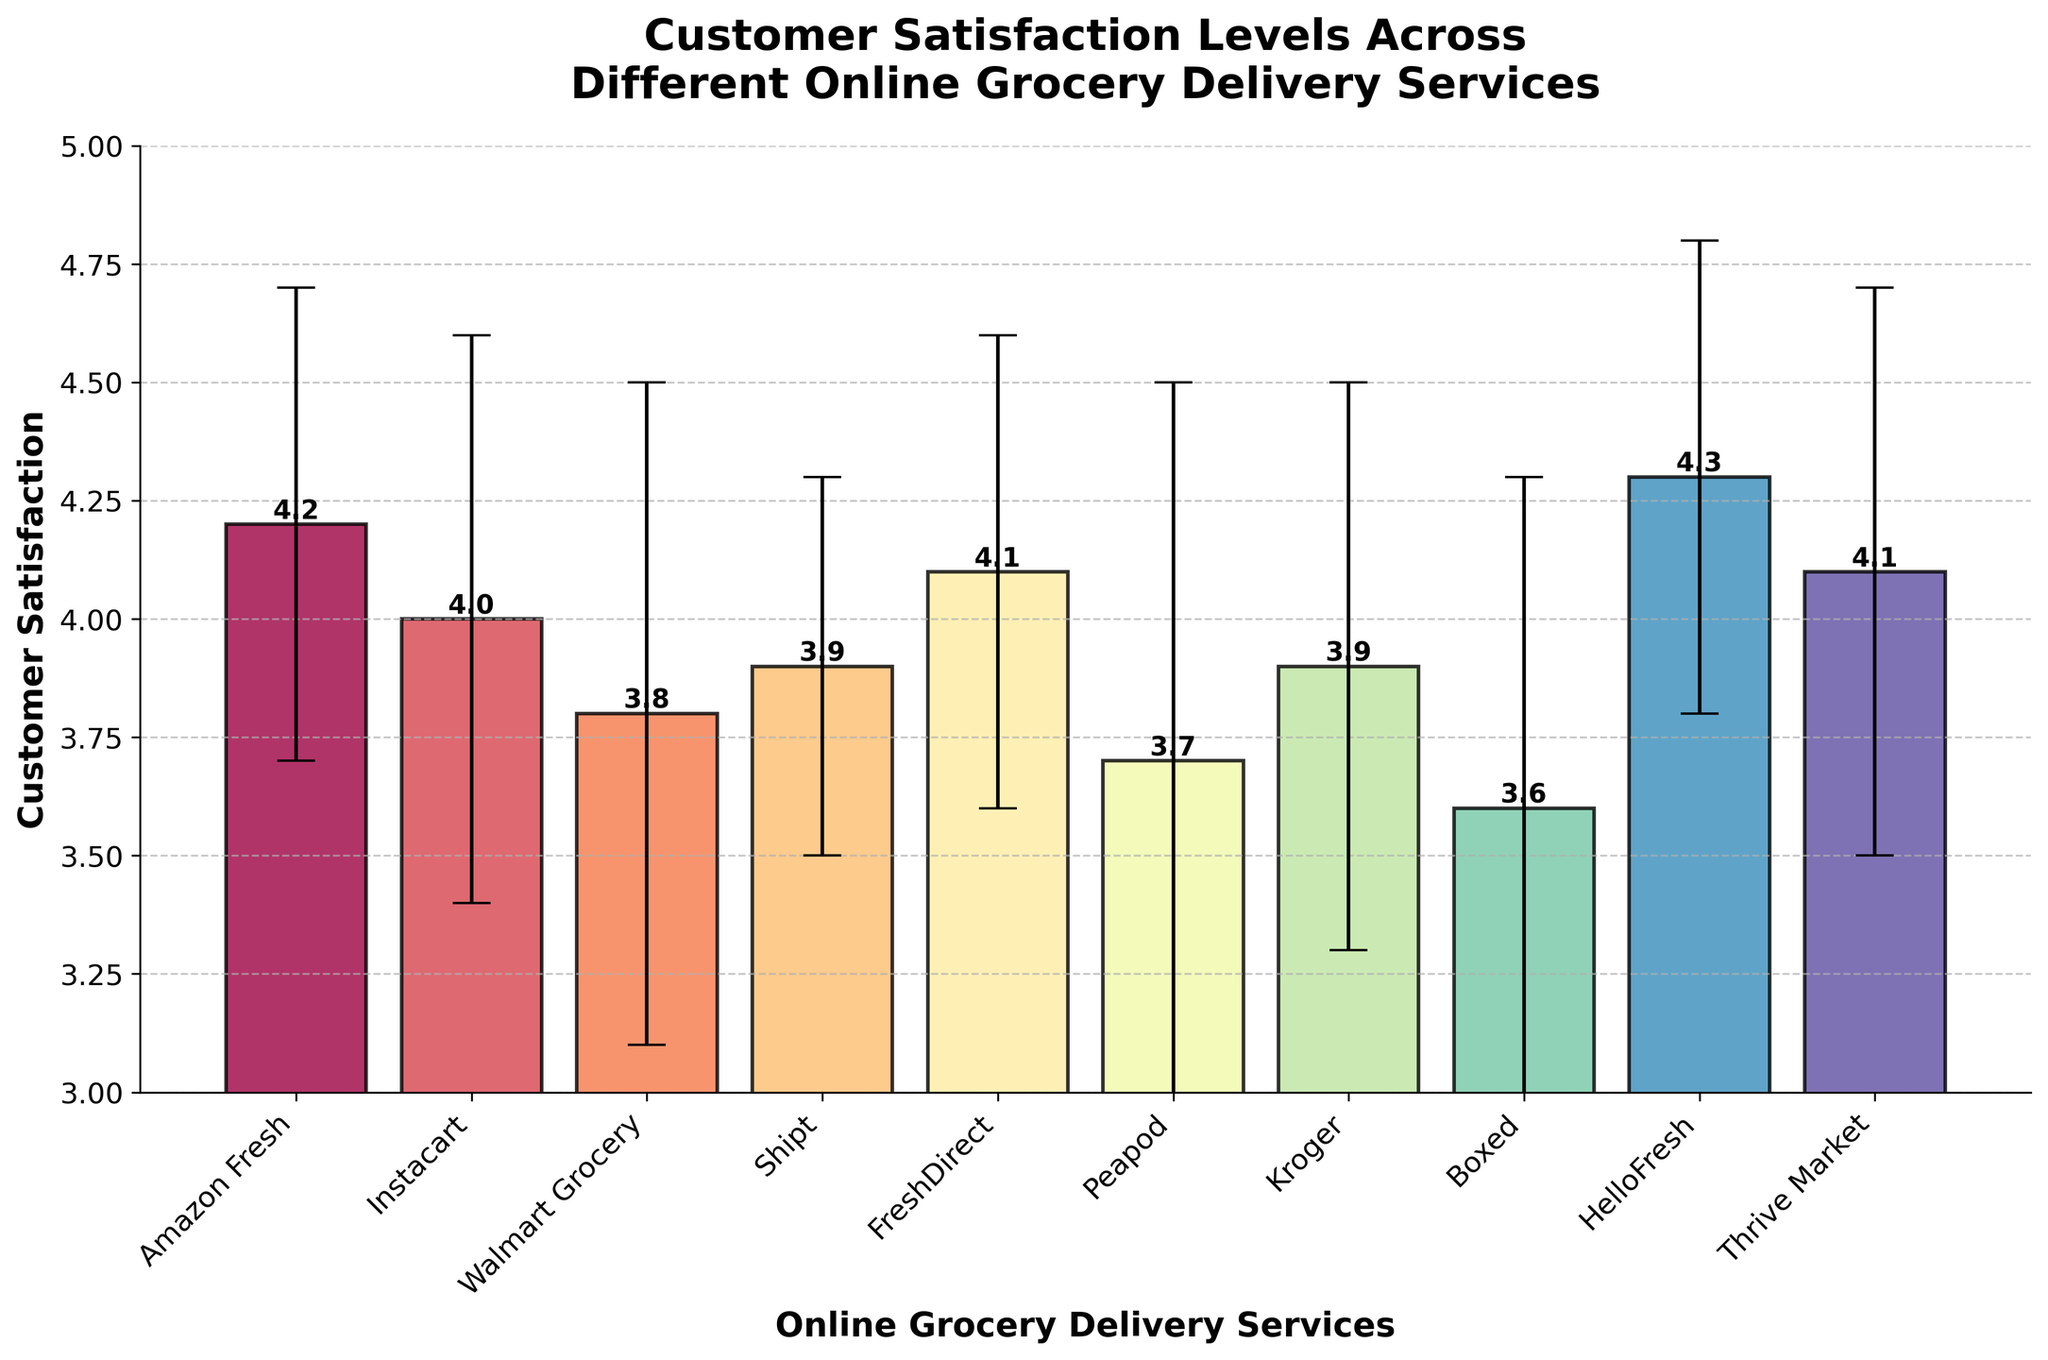What is the title of the figure? The title is the text above the bar chart that describes the overall subject of the chart. It appears in bold at the top center of the figure.
Answer: Customer Satisfaction Levels Across Different Online Grocery Delivery Services What is the average customer satisfaction score for Amazon Fresh? Find the bar that corresponds to Amazon Fresh, and look for the height of the bar, which represents the mean satisfaction.
Answer: 4.2 Which service has the lowest mean customer satisfaction? Look for the shortest bar in the chart, as it represents the lowest mean satisfaction score. Read the label beneath this bar.
Answer: Boxed What is the range of mean satisfaction levels across all services? Identify the highest and lowest bars, subtract the value of the lowest bar from the value of the highest bar.
Answer: 0.7 (4.3 - 3.6) How does the error bar for Shipt compare to the error bar for Walmart Grocery? Look at both the length of the error bars (the vertical lines) for Shipt and Walmart Grocery. Compare their lengths to determine which one is longer.
Answer: Shipt's error bar is shorter Which service has a mean satisfaction exactly equal to 4.1? Locate the bar(s) that reach the 4.1 mark on the y-axis. Determine the service name(s) from the x-axis label(s) of these bar(s).
Answer: FreshDirect and Thrive Market Which service has the highest variability in customer satisfaction? Look for the bar with the tallest error bar (longest vertical line), which represents the highest standard deviation. Read the label beneath this bar.
Answer: Peapod Order the services by decreasing mean satisfaction score. Arrange the service names in order from the highest bar to the shortest bar.
Answer: HelloFresh, Amazon Fresh, FreshDirect, Thrive Market, Instacart, Shipt, Kroger, Walmart Grocery, Peapod, Boxed How does the mean satisfaction score for Instacart compare to Walmart Grocery? Find the heights of the bars for Instacart and Walmart Grocery and compare them. Determine which one is higher.
Answer: Instacart's mean satisfaction score is higher What is the median mean satisfaction score across all services? List all mean satisfaction scores, sort them, and find the middle value. If there is an even number of services, calculate the average of the two central values.
Answer: 4.0 (middle value in sorted list [3.6, 3.7, 3.8, 3.9, 3.9, 4.0, 4.1, 4.1, 4.2, 4.3]) 